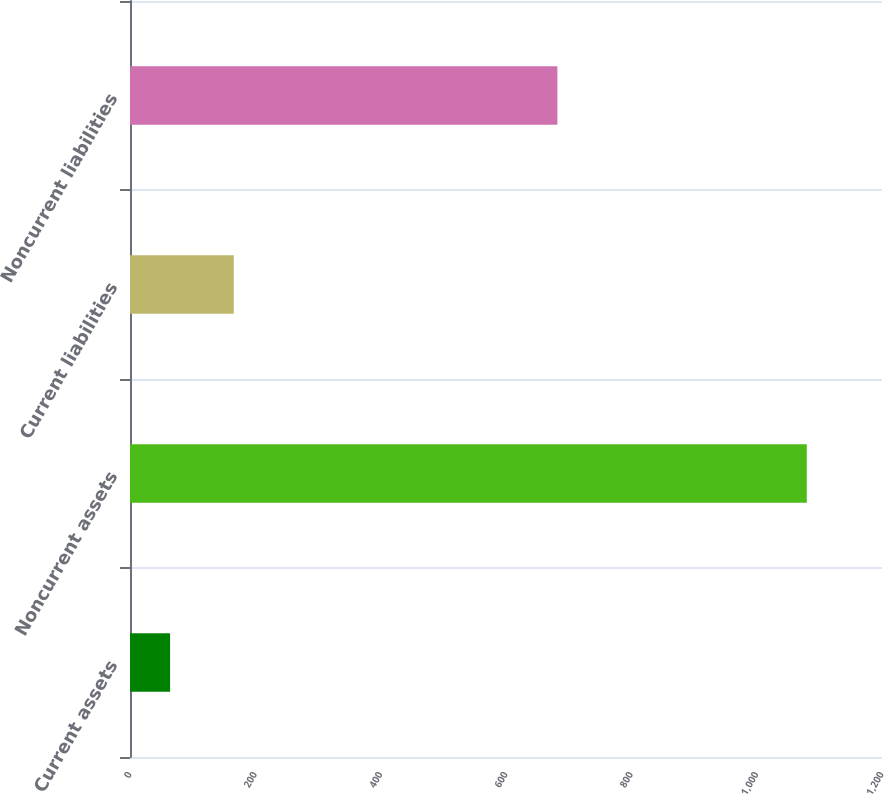<chart> <loc_0><loc_0><loc_500><loc_500><bar_chart><fcel>Current assets<fcel>Noncurrent assets<fcel>Current liabilities<fcel>Noncurrent liabilities<nl><fcel>64<fcel>1080<fcel>165.6<fcel>682<nl></chart> 